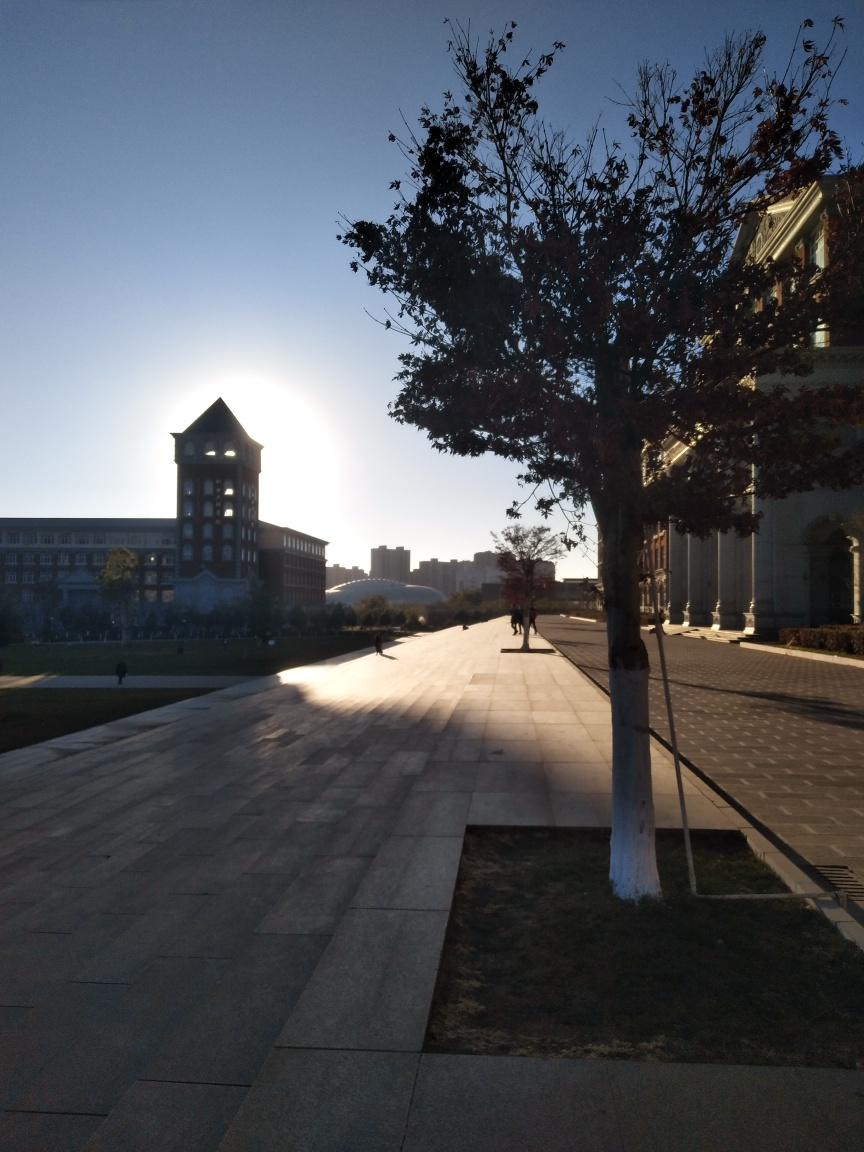What kind of activities seem suitable for the open area shown in the image? The open space in the image, with its expansive paved area, seems ideal for walking, cycling, or other leisurely activities. It's a peaceful setting that could also be used for gatherings, socializing, or simply enjoying the surrounding view. 